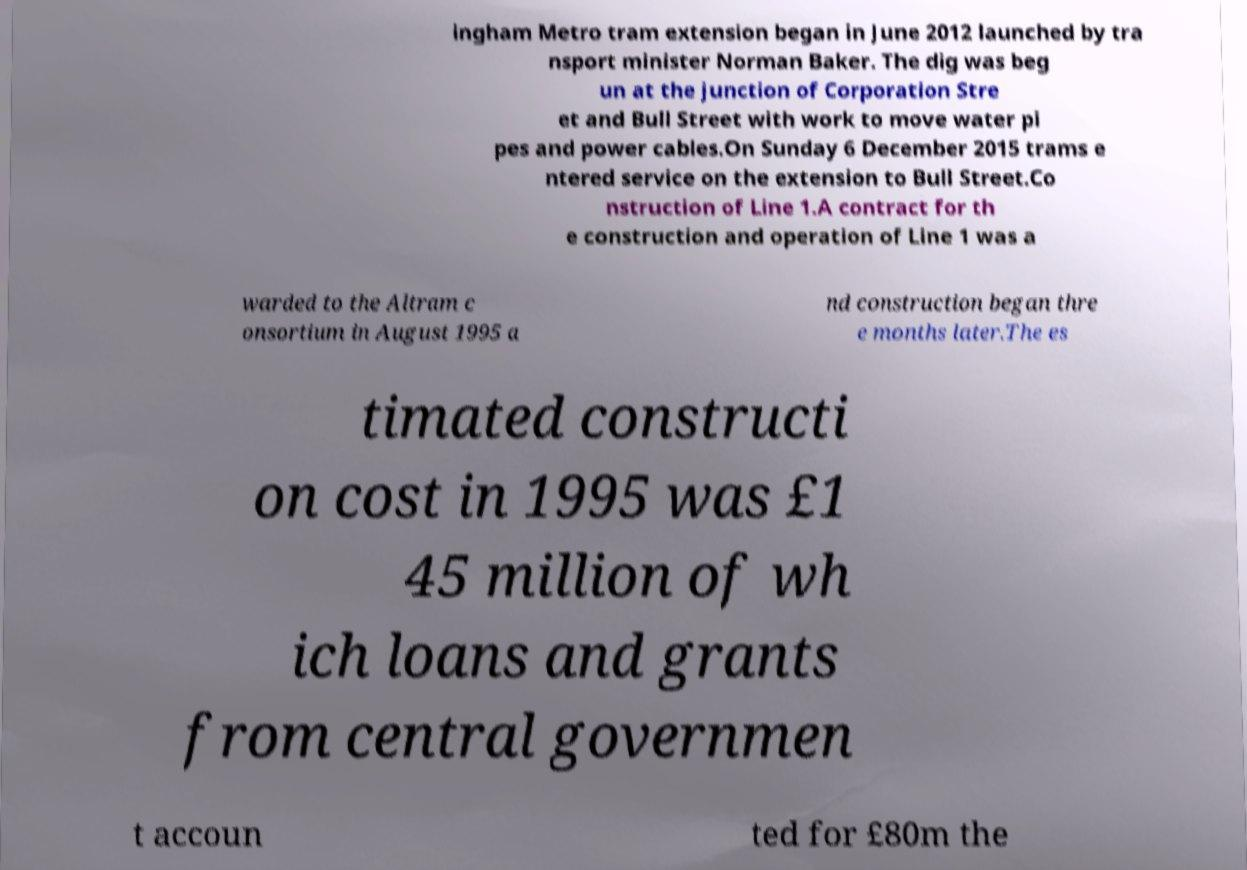Please identify and transcribe the text found in this image. ingham Metro tram extension began in June 2012 launched by tra nsport minister Norman Baker. The dig was beg un at the junction of Corporation Stre et and Bull Street with work to move water pi pes and power cables.On Sunday 6 December 2015 trams e ntered service on the extension to Bull Street.Co nstruction of Line 1.A contract for th e construction and operation of Line 1 was a warded to the Altram c onsortium in August 1995 a nd construction began thre e months later.The es timated constructi on cost in 1995 was £1 45 million of wh ich loans and grants from central governmen t accoun ted for £80m the 